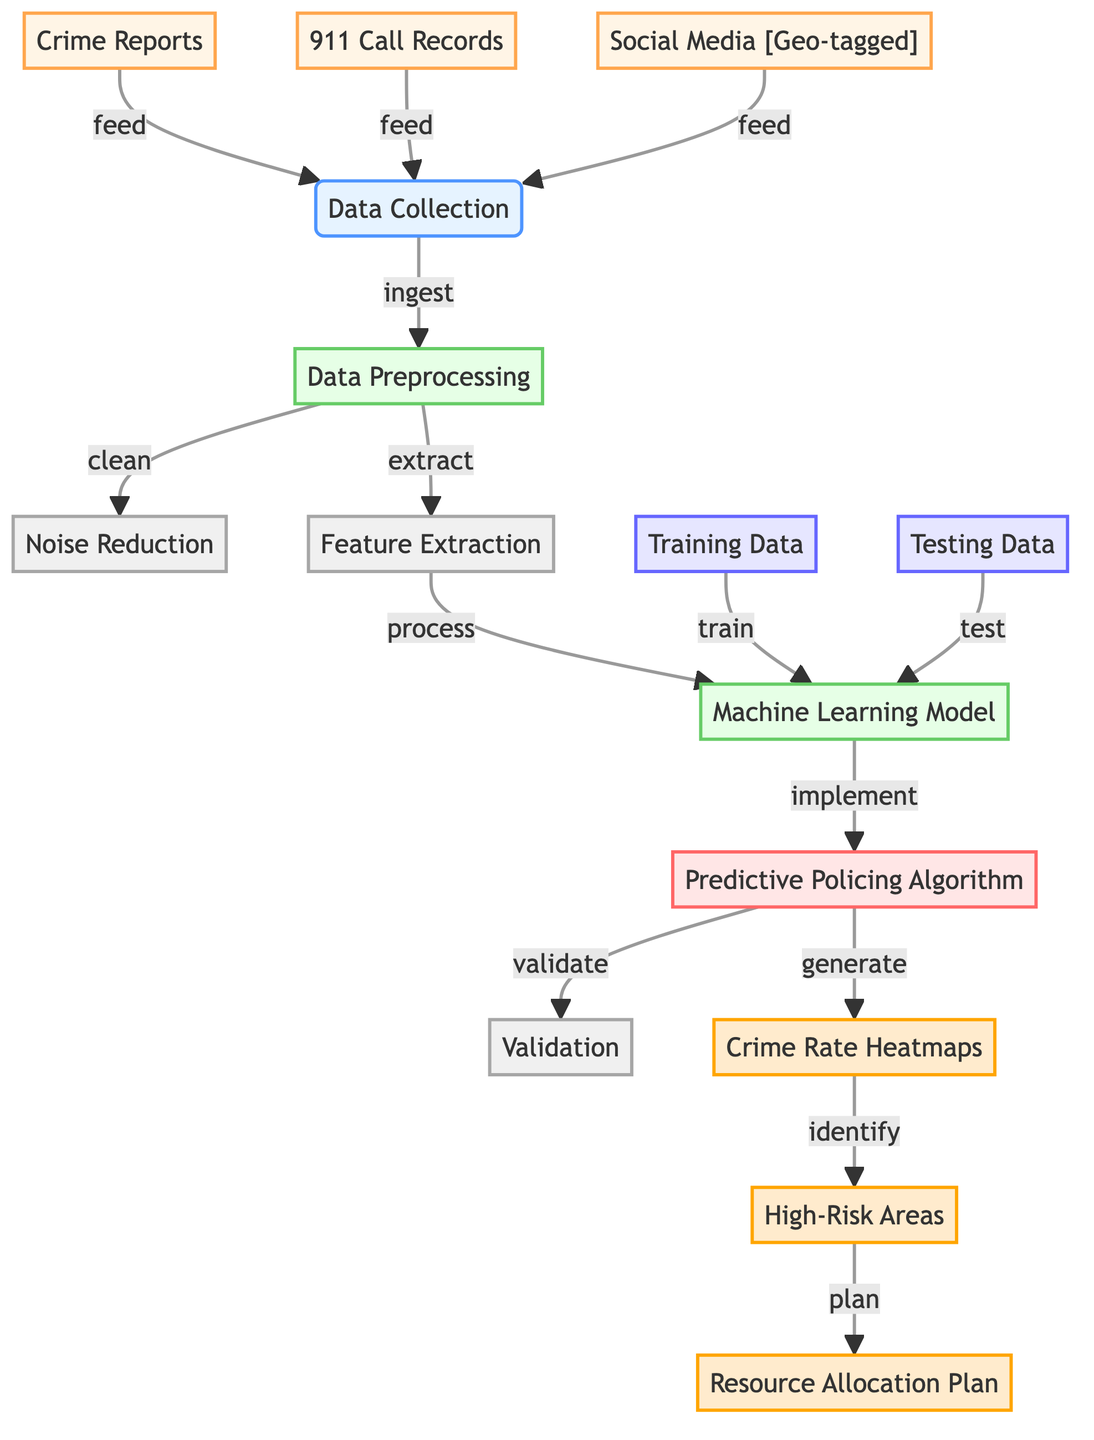What are the data sources used for data collection? The diagram lists three data sources fed into the data collection node: Crime Reports, 911 Call Records, and Social Media [Geo-tagged].
Answer: Crime Reports, 911 Call Records, Social Media [Geo-tagged] How many subprocesses are in the data preprocessing phase? The data preprocessing phase contains two subprocesses: Noise Reduction and Feature Extraction. This is determined by counting the subprocesses connected to the Data Preprocessing node.
Answer: 2 What is the output of the predictive policing algorithm? The predictive policing algorithm generates three outputs: Crime Rate Heatmaps, High-Risk Areas, and Resource Allocation Plan. Each output is directly connected to the Predictive Policing Algorithm node.
Answer: Crime Rate Heatmaps, High-Risk Areas, Resource Allocation Plan What comes after training data in the diagram? After Training Data, the next step indicated in the diagram is Testing Data. This is shown by the flow from Training Data directly to the Machine Learning Model node.
Answer: Testing Data Which process is responsible for identifying high-risk areas? The process that identifies high-risk areas is the predictive policing algorithm. The diagram shows that it is the direct output of the algorithm generating Crime Rate Heatmaps as well.
Answer: Predictive Policing Algorithm What is the function of the noise reduction subprocess? The noise reduction subprocess functions to clean the data in the data preprocessing phase. It is linked to the data preprocessing node and is described as a cleaning task.
Answer: Clean How do high-risk areas relate to the resource allocation plan? High-risk areas are identified as an output of the Crime Rate Heatmaps, which then inform the Resource Allocation Plan. This indicates a flow from High-Risk Areas to Resource Allocation Plan in the diagram.
Answer: Inform What is the classification style used for data sources? The data sources are classified with a style that has a fill of #fff5e6 and a stroke of #ffa64d, indicating that they are external data sources used for input.
Answer: fill:#fff5e6,stroke:#ffa64d How does the machine learning model interact with the training and testing data? The machine learning model first uses Training Data to train and then Testing Data to evaluate its performance. This is depicted with arrows showing direct relationships from these nodes to the Machine Learning Model.
Answer: Train and Test 